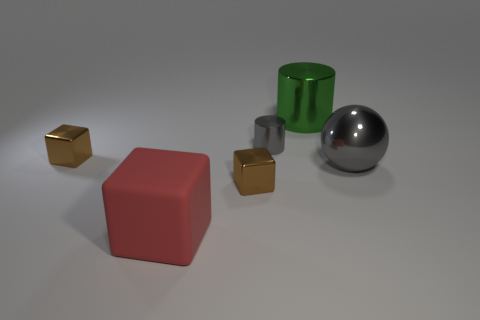What is the shape of the small metallic thing that is the same color as the metallic ball?
Provide a short and direct response. Cylinder. Are there any other things that have the same material as the big red thing?
Keep it short and to the point. No. What number of brown blocks are in front of the gray object to the right of the cylinder in front of the green metal cylinder?
Your response must be concise. 1. There is a metallic object that is in front of the small gray cylinder and behind the large gray metallic ball; what color is it?
Ensure brevity in your answer.  Brown. What number of small objects are the same color as the big ball?
Ensure brevity in your answer.  1. How many blocks are tiny yellow objects or red objects?
Offer a terse response. 1. What is the color of the cylinder that is the same size as the matte cube?
Your response must be concise. Green. There is a brown metallic object that is in front of the tiny brown thing behind the metal ball; is there a red rubber thing right of it?
Your answer should be compact. No. The gray shiny cylinder has what size?
Your response must be concise. Small. How many things are gray metallic cylinders or small brown metal cubes?
Make the answer very short. 3. 